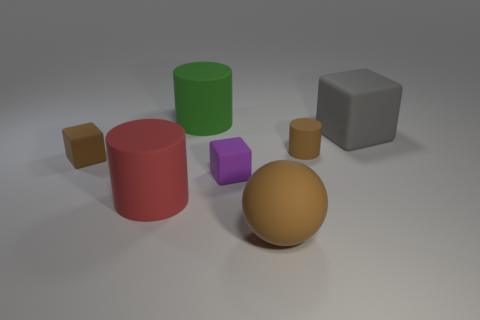Add 2 tiny purple blocks. How many objects exist? 9 Subtract all cylinders. How many objects are left? 4 Subtract 0 gray cylinders. How many objects are left? 7 Subtract all tiny brown cubes. Subtract all big brown rubber things. How many objects are left? 5 Add 5 gray cubes. How many gray cubes are left? 6 Add 3 large green shiny blocks. How many large green shiny blocks exist? 3 